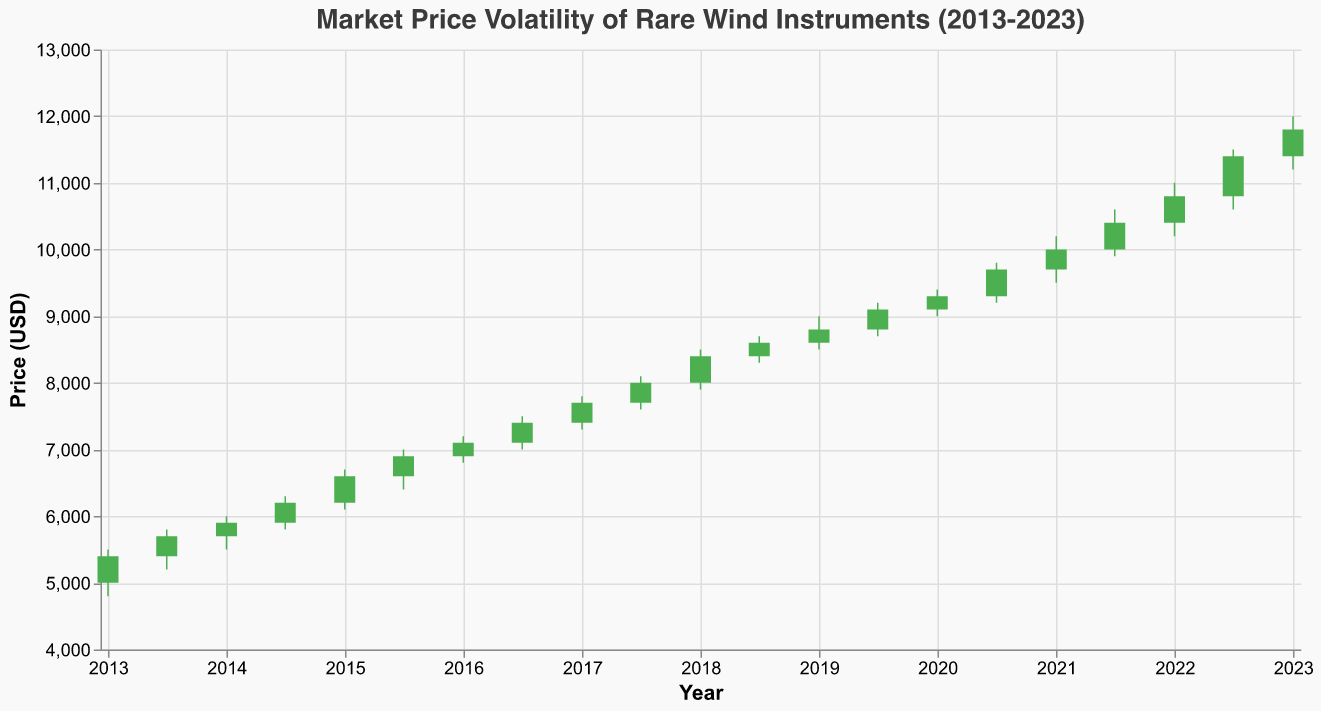What is the highest market price shown in the figure? The highest market price shown corresponds to the High value of the bars. The highest High value in the data is 12000 USD on January 1, 2023.
Answer: 12000 USD Which year had the highest closing price? To answer this, we need to look at the closing price for each year. The highest closing price is 11800 USD in 2023.
Answer: 2023 What is the average opening price from 2013 to 2023? Summing up all the opening prices from 2013 to 2023 and dividing by the number of data points (21) gives us the average. (5000+5400+5700+5900+6200+6600+6900+7100+7400+7700+8000+8400+8600+8800+9100+9300+9700+10000+10400+10800+11400)/21 = 8276.19
Answer: 8276.19 USD Did the closing price ever decline between two data points in consecutive years? We need to check if there was any year where the previous year's closing price was higher than the current year's. The closing price rises in every data point from 5400 in 2013 to 11800 in 2023 without any declines.
Answer: No What is the maximum price swing for a single period shown in the figure? The price swing is the difference between the High and Low values. The maximum swing is in 2020-07-01 with a High of 9800 and a Low of 9200. Thus, the swing is 9800 - 9200 = 600 USD.
Answer: 600 USD Compare the opening price of 2021 with the closing price of 2020. Which one is higher? The opening price of 2021 is 9700 USD while the closing price of 2020 is 9700 USD on the 2020-07-01 date. Both are equal.
Answer: Equal Which period had the lowest closing price? The lowest closing price in the data is at the beginning of the period in 2013-01-01, which is 5400 USD.
Answer: 2013-01-01 Did the low prices ever exceed 10000 USD in any year? Looking at the Low values for each period, the highest Low value is 11200 USD in 2023. Therefore, it exceeded 10000 USD only in 2023.
Answer: Yes, in 2023 What was the market price trend for rare wind instruments from 2013 to 2023? Observing the data points from the start to the end date, we can see a general upward trend in the market prices consistent with increasing open, high, low, and close prices each period from 2013 to 2023.
Answer: Upward trend By how much did the closing price increase from 2015 to 2016? The closing price for 2015-01-01 is 6600 USD, and for 2016-01-01 it is 7100 USD. The increase is 7100 - 6600 = 500 USD.
Answer: 500 USD 